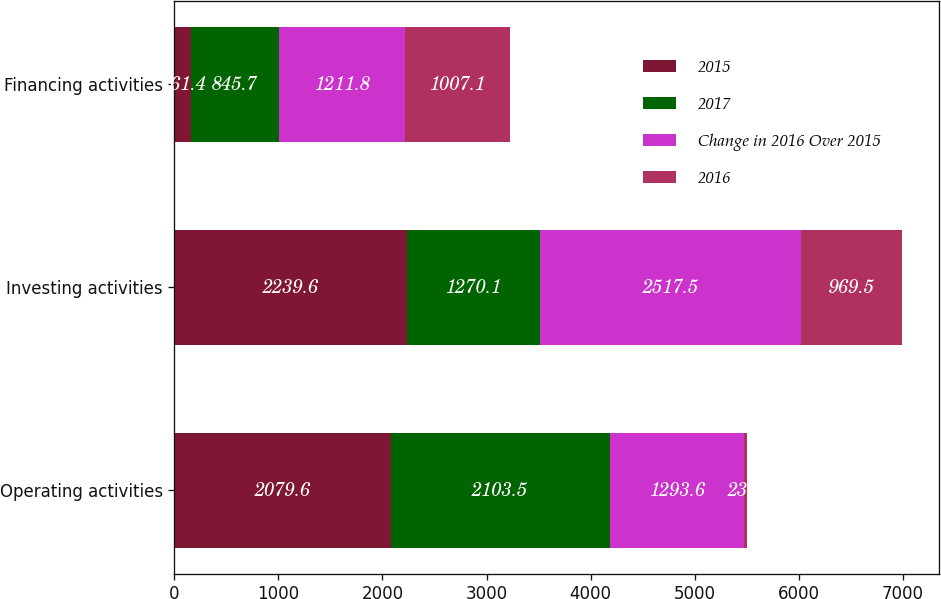Convert chart. <chart><loc_0><loc_0><loc_500><loc_500><stacked_bar_chart><ecel><fcel>Operating activities<fcel>Investing activities<fcel>Financing activities<nl><fcel>2015<fcel>2079.6<fcel>2239.6<fcel>161.4<nl><fcel>2017<fcel>2103.5<fcel>1270.1<fcel>845.7<nl><fcel>Change in 2016 Over 2015<fcel>1293.6<fcel>2517.5<fcel>1211.8<nl><fcel>2016<fcel>23.9<fcel>969.5<fcel>1007.1<nl></chart> 